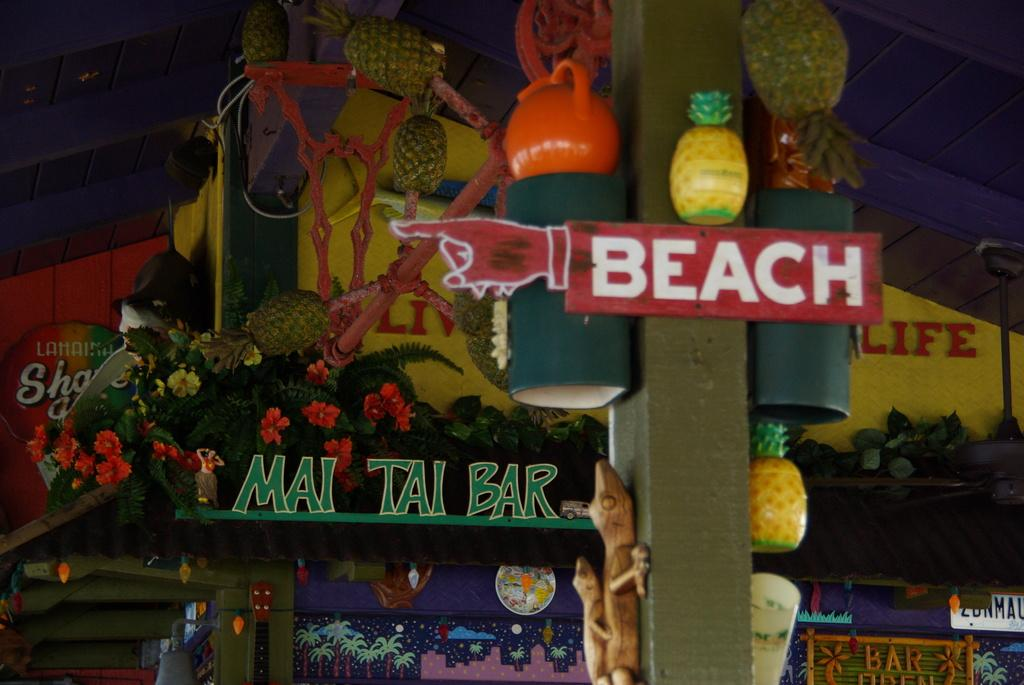<image>
Create a compact narrative representing the image presented. A large sign with a pineapple on the top that reads Beach with a hand pointing to the left. 